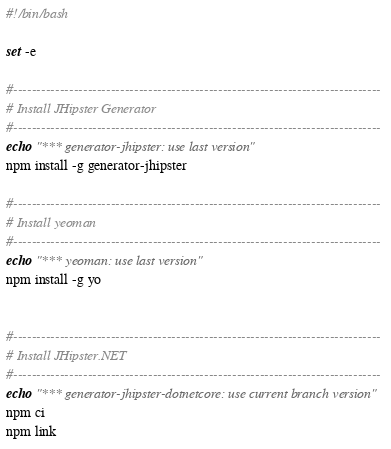Convert code to text. <code><loc_0><loc_0><loc_500><loc_500><_Bash_>#!/bin/bash

set -e

#-------------------------------------------------------------------------------
# Install JHipster Generator
#-------------------------------------------------------------------------------
echo "*** generator-jhipster: use last version"
npm install -g generator-jhipster

#-------------------------------------------------------------------------------
# Install yeoman
#-------------------------------------------------------------------------------
echo "*** yeoman: use last version"
npm install -g yo


#-------------------------------------------------------------------------------
# Install JHipster.NET
#-------------------------------------------------------------------------------
echo "*** generator-jhipster-dotnetcore: use current branch version"
npm ci
npm link</code> 